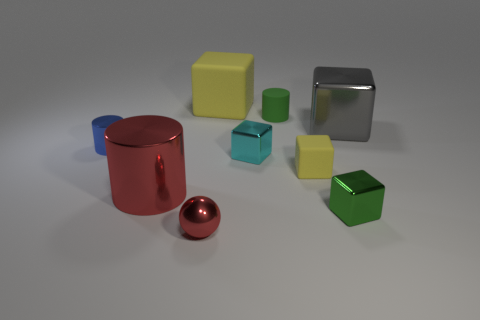Imagine these objects are part of a learning game for children. Could you suggest a possible game using these items? Absolutely! One educational game could involve color and shape matching. Children could be asked to group the objects by color or shape and then describe the differences in their surfaces. For an advanced level, they could speculate on the materials of the objects based on light reflection and texture, encouraging observation and critical thinking skills. 